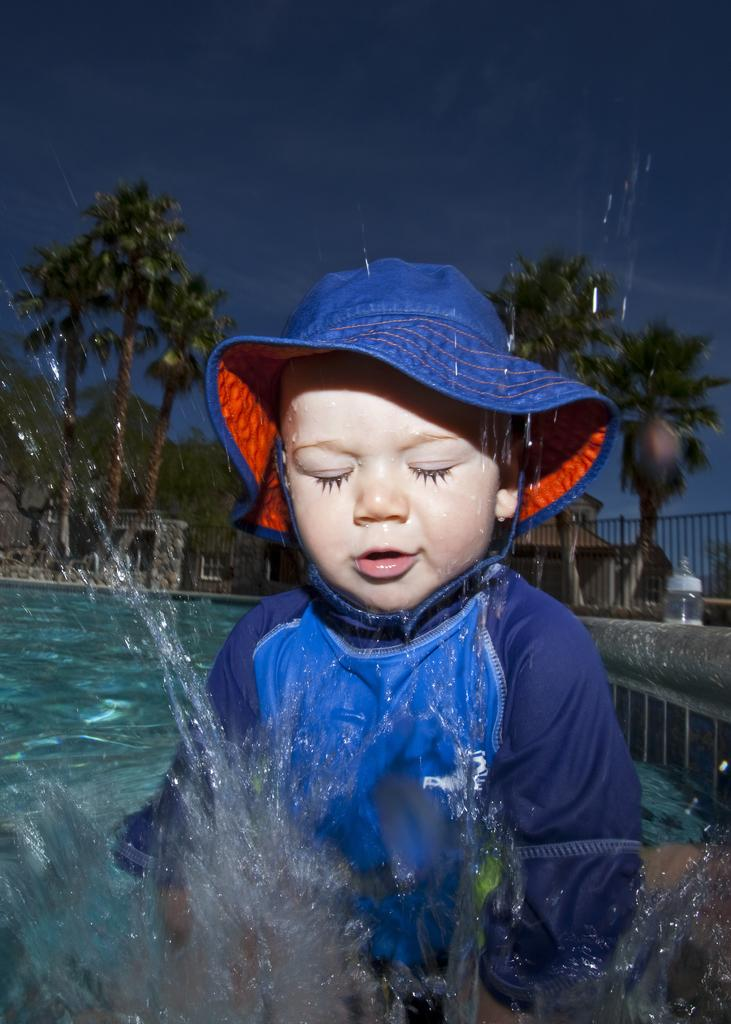What is the main subject of the image? The main subject of the image is a kid in the water. What is the kid wearing? The kid is wearing a hat and a coat. What can be seen in the background of the image? There are trees, buildings, a fence, and a bottle in the background of the image. What is visible at the top of the image? The sky is visible at the top of the image. How much sugar is in the bottle in the background of the image? There is no bottle of sugar present in the image; it is a regular bottle. What type of calendar is hanging on the fence in the background of the image? There is no calendar visible in the image; only a fence is present in the background. 